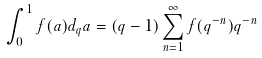<formula> <loc_0><loc_0><loc_500><loc_500>\int _ { 0 } ^ { 1 } f ( a ) d _ { q } a = ( q - 1 ) \sum _ { n = 1 } ^ { \infty } f ( q ^ { - n } ) q ^ { - n }</formula> 